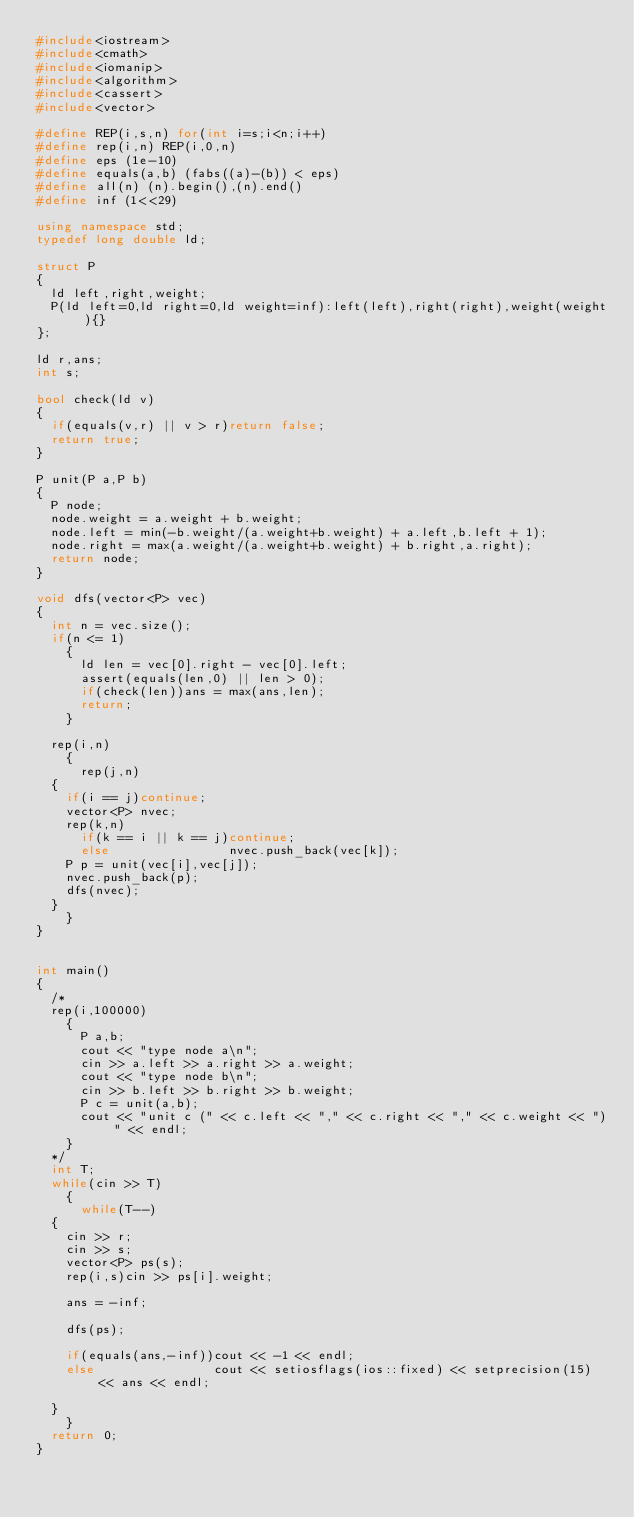<code> <loc_0><loc_0><loc_500><loc_500><_C++_>#include<iostream>
#include<cmath>
#include<iomanip>
#include<algorithm>
#include<cassert>
#include<vector>

#define REP(i,s,n) for(int i=s;i<n;i++)
#define rep(i,n) REP(i,0,n)
#define eps (1e-10)
#define equals(a,b) (fabs((a)-(b)) < eps)
#define all(n) (n).begin(),(n).end()
#define inf (1<<29)

using namespace std;
typedef long double ld;

struct P
{
  ld left,right,weight;
  P(ld left=0,ld right=0,ld weight=inf):left(left),right(right),weight(weight){}
};

ld r,ans;
int s;

bool check(ld v)
{
  if(equals(v,r) || v > r)return false;
  return true;
}

P unit(P a,P b)
{
  P node;
  node.weight = a.weight + b.weight;
  node.left = min(-b.weight/(a.weight+b.weight) + a.left,b.left + 1);
  node.right = max(a.weight/(a.weight+b.weight) + b.right,a.right);
  return node;
}

void dfs(vector<P> vec)
{
  int n = vec.size();
  if(n <= 1)
    {
      ld len = vec[0].right - vec[0].left;
      assert(equals(len,0) || len > 0);
      if(check(len))ans = max(ans,len);
      return;
    }

  rep(i,n)
    {
      rep(j,n)
	{
	  if(i == j)continue;
	  vector<P> nvec;
	  rep(k,n)
	    if(k == i || k == j)continue;
	    else                nvec.push_back(vec[k]);
	  P p = unit(vec[i],vec[j]);
	  nvec.push_back(p);
	  dfs(nvec);
	}
    }
}


int main()
{
  /*
  rep(i,100000)
    {
      P a,b;
      cout << "type node a\n";
      cin >> a.left >> a.right >> a.weight;
      cout << "type node b\n";
      cin >> b.left >> b.right >> b.weight;
      P c = unit(a,b);
      cout << "unit c (" << c.left << "," << c.right << "," << c.weight << ")" << endl;
    }
  */
  int T;
  while(cin >> T)
    {
      while(T--)
	{
	  cin >> r;
	  cin >> s;
	  vector<P> ps(s);
	  rep(i,s)cin >> ps[i].weight;

	  ans = -inf;

	  dfs(ps);
	  
	  if(equals(ans,-inf))cout << -1 << endl;
	  else                cout << setiosflags(ios::fixed) << setprecision(15) << ans << endl;

	}
    }
  return 0;
}</code> 